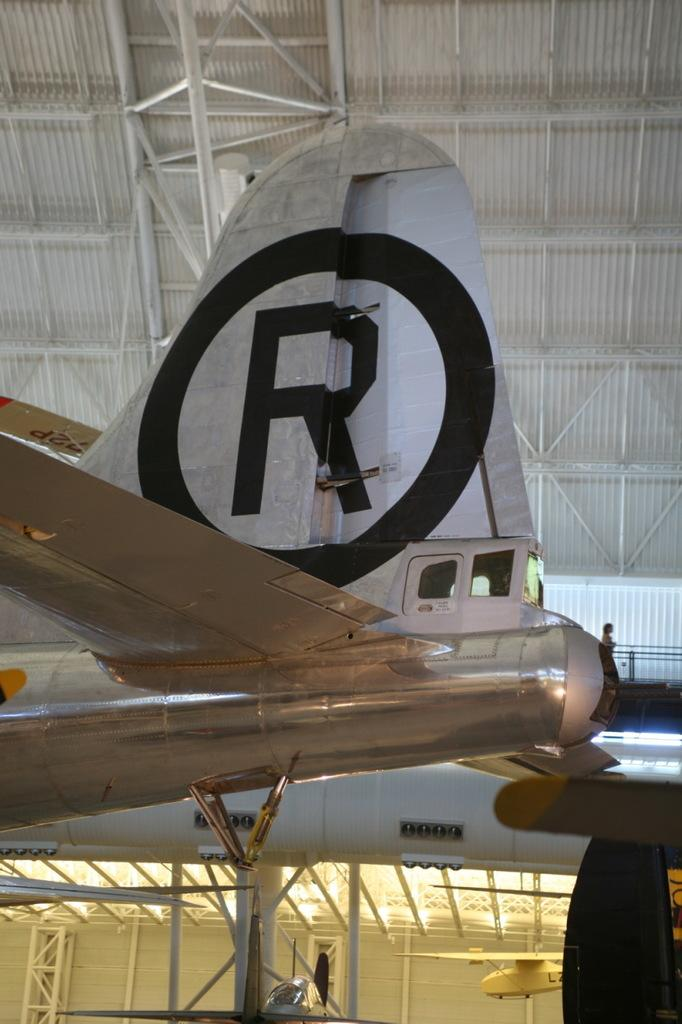What is the main subject of the image? The main subject of the image is an aeroplane. Can you describe any other structures or objects in the image? Yes, there is an iron shed in white color at the top of the image. What type of tools does the carpenter use in the image? There is no carpenter present in the image, so it is not possible to determine what tools they might use. 